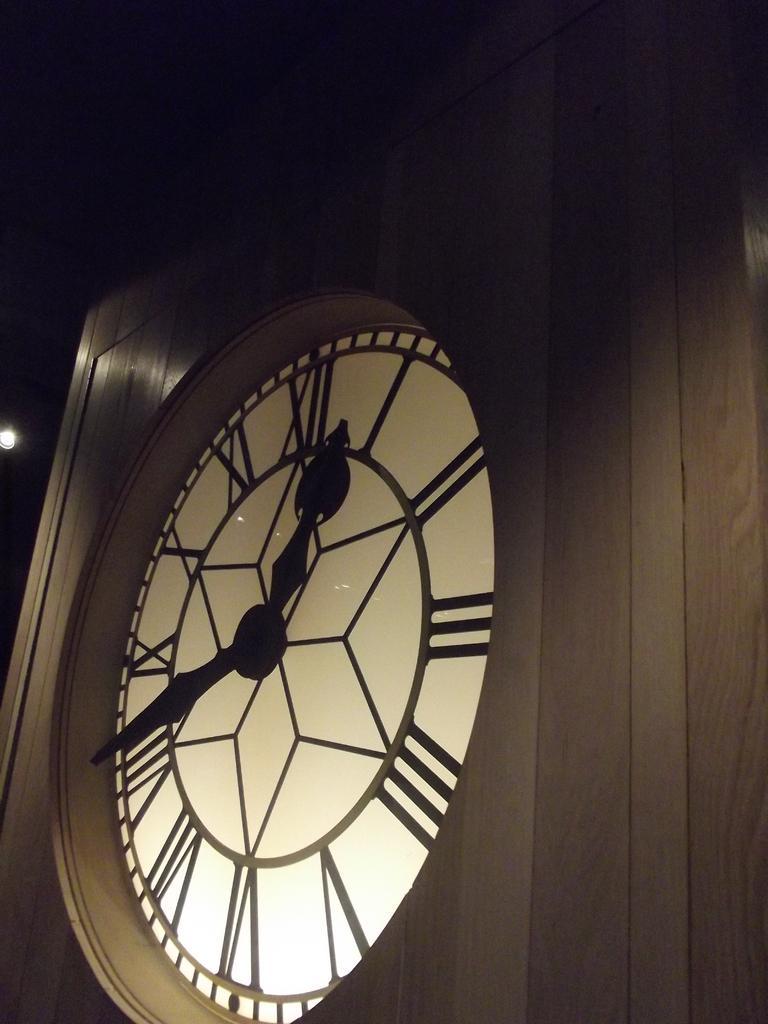Could you give a brief overview of what you see in this image? In this image there is a clock in the wooden wall with minute hand and a hour hand, and there is dark background. 